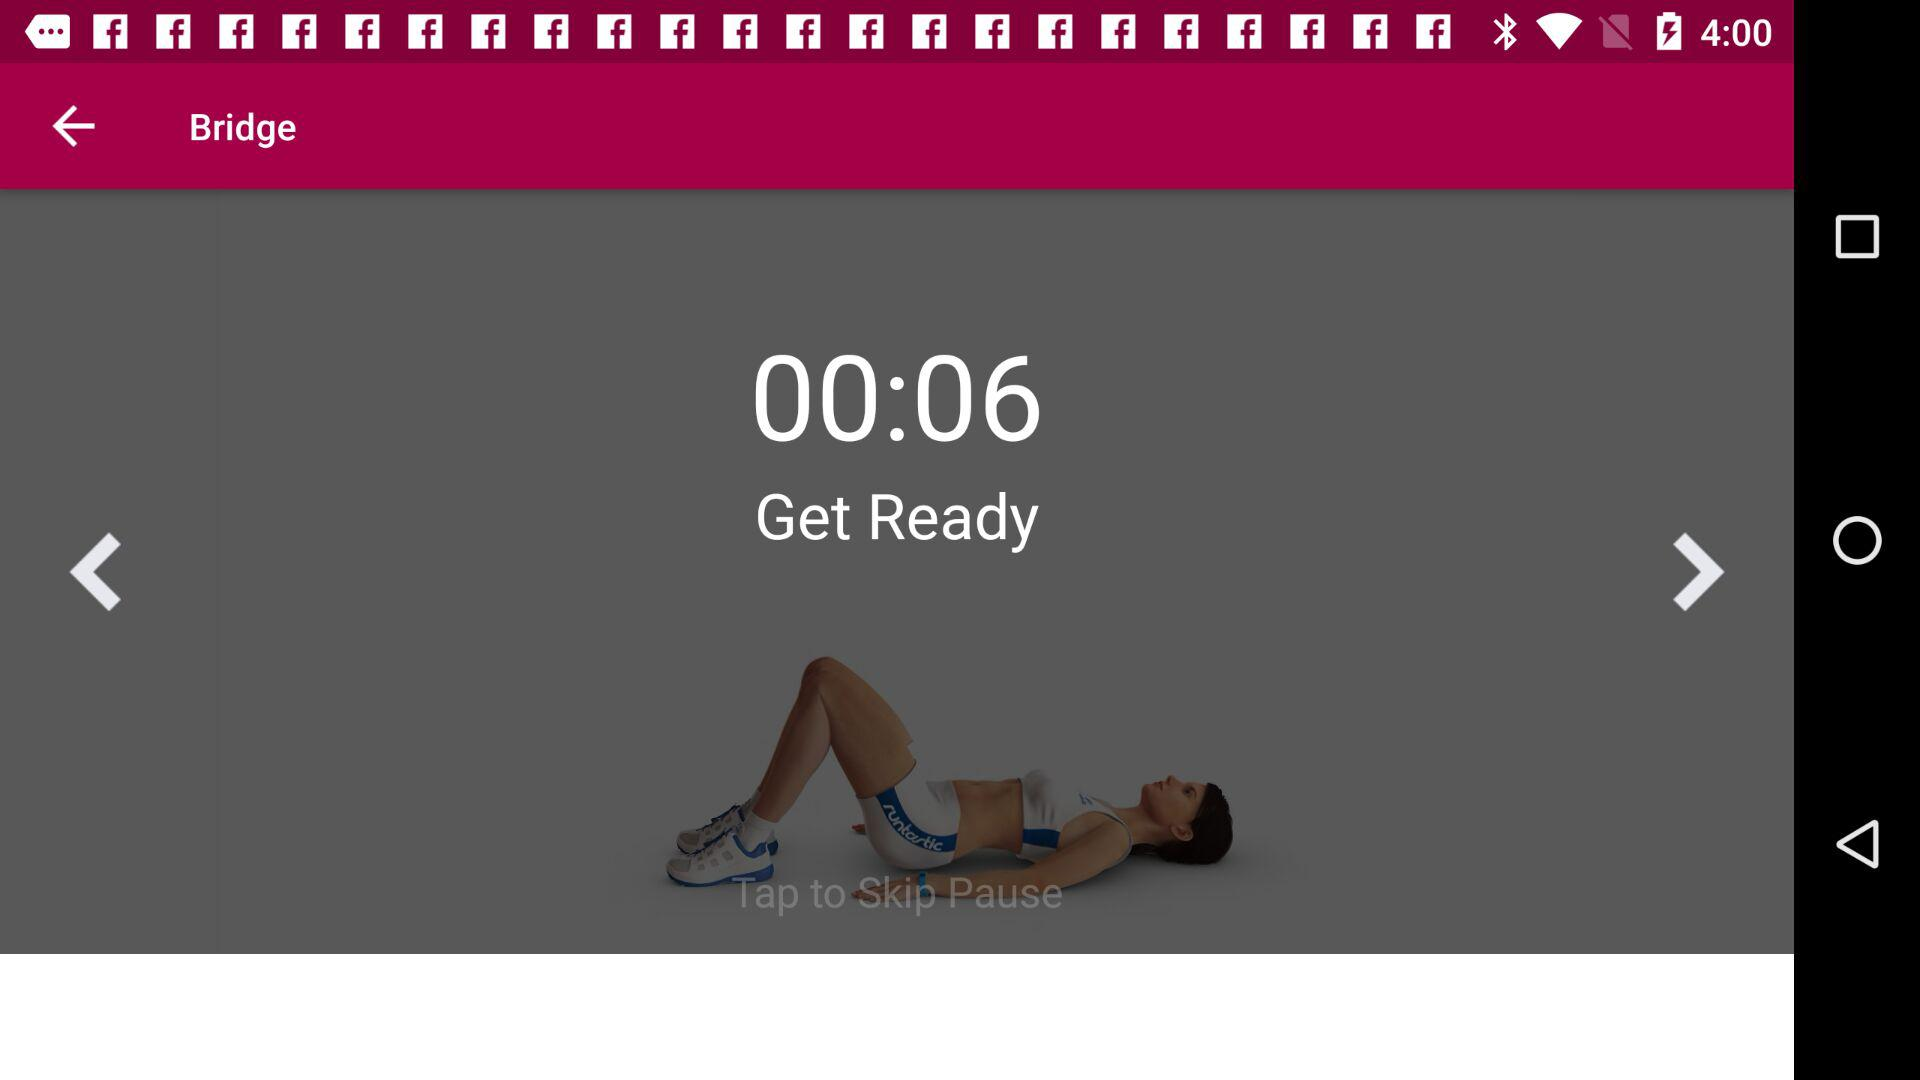What does level 1 determine? Level 1 determines "Commence your journey". 